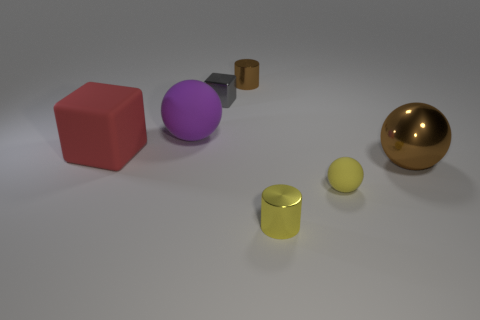There is a tiny object that is right of the gray metallic thing and behind the big brown thing; what is it made of? The small object positioned to the right of the gray metallic cylinder and behind the larger brown box appears to be constructed from metal, similar in sheen and texture to the gray cylinder. 